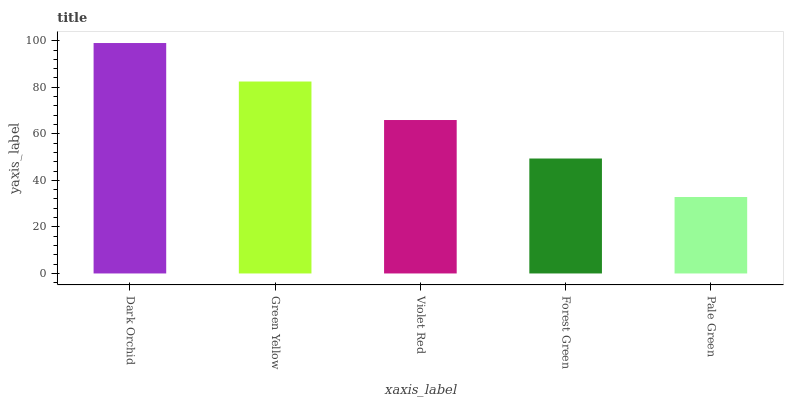Is Pale Green the minimum?
Answer yes or no. Yes. Is Dark Orchid the maximum?
Answer yes or no. Yes. Is Green Yellow the minimum?
Answer yes or no. No. Is Green Yellow the maximum?
Answer yes or no. No. Is Dark Orchid greater than Green Yellow?
Answer yes or no. Yes. Is Green Yellow less than Dark Orchid?
Answer yes or no. Yes. Is Green Yellow greater than Dark Orchid?
Answer yes or no. No. Is Dark Orchid less than Green Yellow?
Answer yes or no. No. Is Violet Red the high median?
Answer yes or no. Yes. Is Violet Red the low median?
Answer yes or no. Yes. Is Pale Green the high median?
Answer yes or no. No. Is Forest Green the low median?
Answer yes or no. No. 